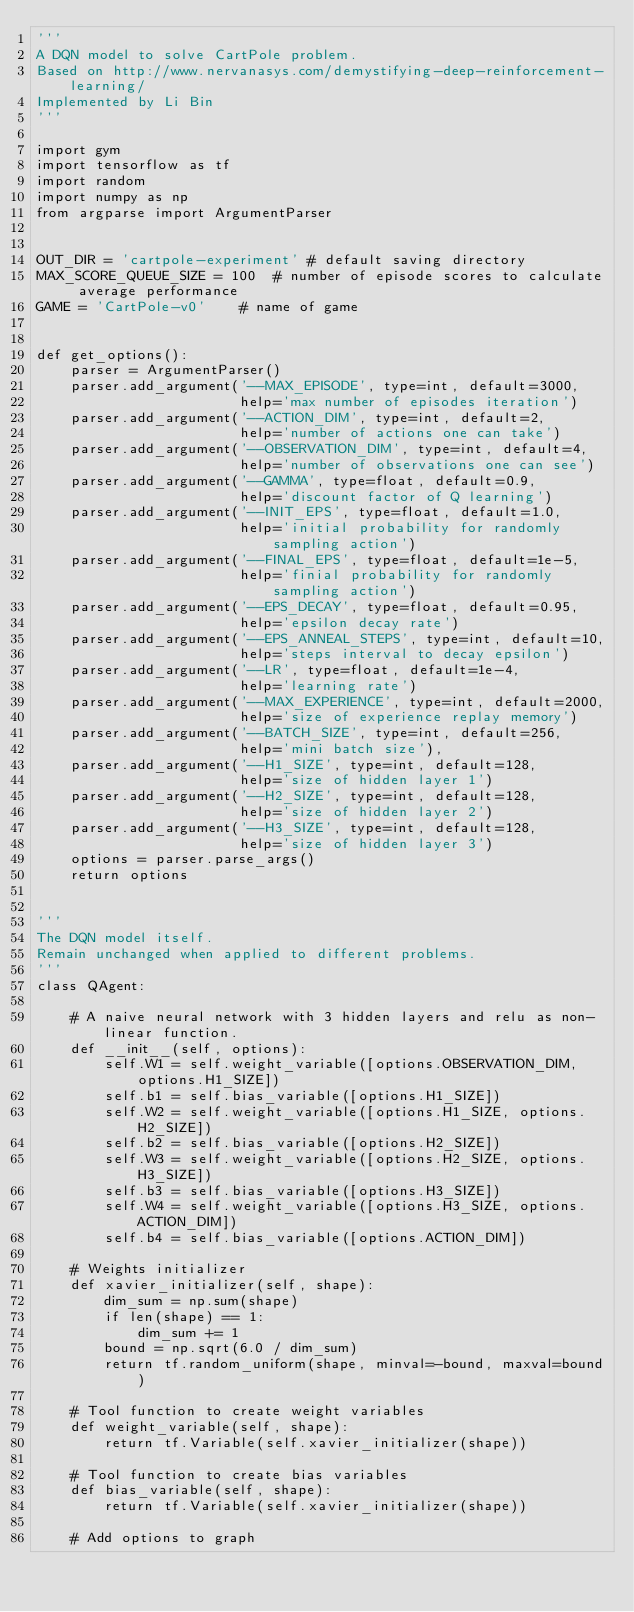<code> <loc_0><loc_0><loc_500><loc_500><_Python_>'''
A DQN model to solve CartPole problem.
Based on http://www.nervanasys.com/demystifying-deep-reinforcement-learning/
Implemented by Li Bin
'''

import gym
import tensorflow as tf
import random
import numpy as np
from argparse import ArgumentParser


OUT_DIR = 'cartpole-experiment' # default saving directory
MAX_SCORE_QUEUE_SIZE = 100  # number of episode scores to calculate average performance
GAME = 'CartPole-v0'    # name of game


def get_options():
    parser = ArgumentParser()
    parser.add_argument('--MAX_EPISODE', type=int, default=3000,
                        help='max number of episodes iteration')
    parser.add_argument('--ACTION_DIM', type=int, default=2,
                        help='number of actions one can take')
    parser.add_argument('--OBSERVATION_DIM', type=int, default=4,
                        help='number of observations one can see')
    parser.add_argument('--GAMMA', type=float, default=0.9,
                        help='discount factor of Q learning')
    parser.add_argument('--INIT_EPS', type=float, default=1.0,
                        help='initial probability for randomly sampling action')
    parser.add_argument('--FINAL_EPS', type=float, default=1e-5,
                        help='finial probability for randomly sampling action')
    parser.add_argument('--EPS_DECAY', type=float, default=0.95,
                        help='epsilon decay rate')
    parser.add_argument('--EPS_ANNEAL_STEPS', type=int, default=10,
                        help='steps interval to decay epsilon')
    parser.add_argument('--LR', type=float, default=1e-4,
                        help='learning rate')
    parser.add_argument('--MAX_EXPERIENCE', type=int, default=2000,
                        help='size of experience replay memory')
    parser.add_argument('--BATCH_SIZE', type=int, default=256,
                        help='mini batch size'),
    parser.add_argument('--H1_SIZE', type=int, default=128,
                        help='size of hidden layer 1')
    parser.add_argument('--H2_SIZE', type=int, default=128,
                        help='size of hidden layer 2')
    parser.add_argument('--H3_SIZE', type=int, default=128,
                        help='size of hidden layer 3')
    options = parser.parse_args()
    return options


'''
The DQN model itself.
Remain unchanged when applied to different problems.
'''
class QAgent:
    
    # A naive neural network with 3 hidden layers and relu as non-linear function.
    def __init__(self, options):
        self.W1 = self.weight_variable([options.OBSERVATION_DIM, options.H1_SIZE])
        self.b1 = self.bias_variable([options.H1_SIZE])
        self.W2 = self.weight_variable([options.H1_SIZE, options.H2_SIZE])
        self.b2 = self.bias_variable([options.H2_SIZE])
        self.W3 = self.weight_variable([options.H2_SIZE, options.H3_SIZE])
        self.b3 = self.bias_variable([options.H3_SIZE])
        self.W4 = self.weight_variable([options.H3_SIZE, options.ACTION_DIM])
        self.b4 = self.bias_variable([options.ACTION_DIM])
    
    # Weights initializer
    def xavier_initializer(self, shape):
        dim_sum = np.sum(shape)
        if len(shape) == 1:
            dim_sum += 1
        bound = np.sqrt(6.0 / dim_sum)
        return tf.random_uniform(shape, minval=-bound, maxval=bound)

    # Tool function to create weight variables
    def weight_variable(self, shape):
        return tf.Variable(self.xavier_initializer(shape))

    # Tool function to create bias variables
    def bias_variable(self, shape):
        return tf.Variable(self.xavier_initializer(shape))

    # Add options to graph</code> 